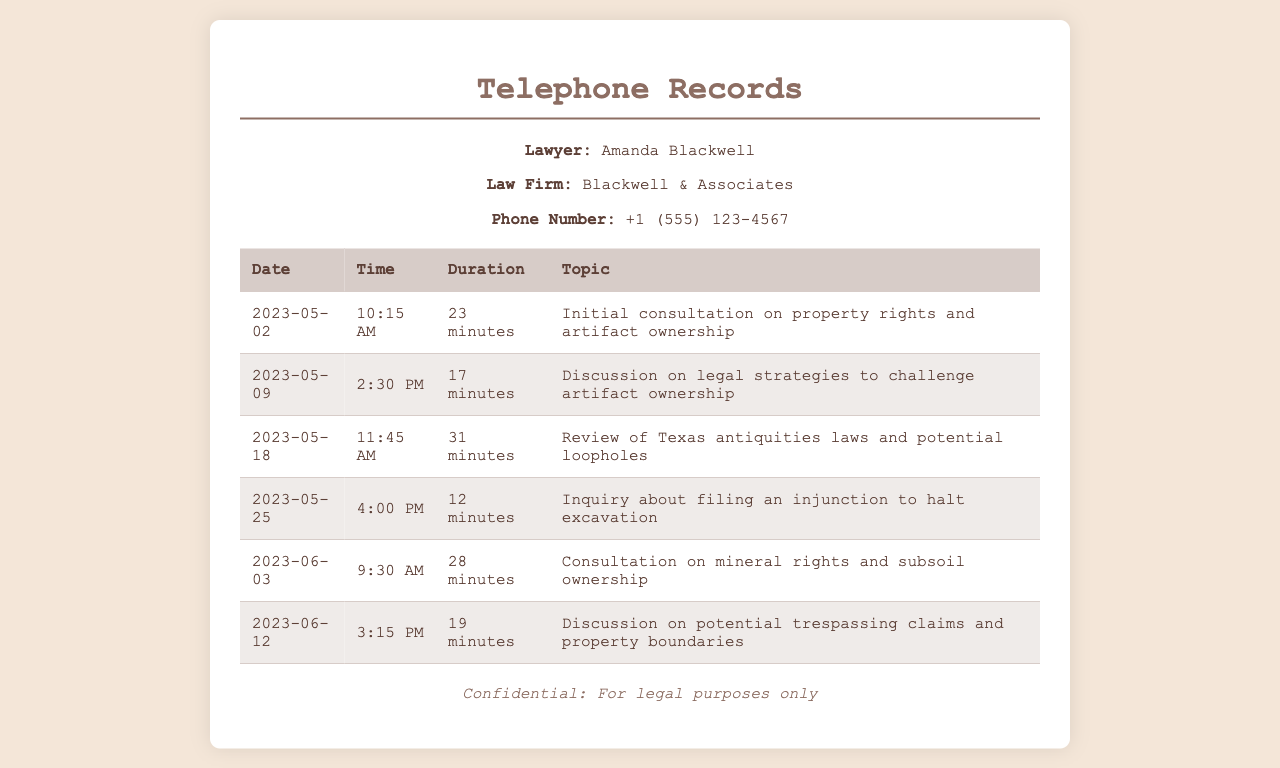What is the name of the lawyer? The lawyer's name is mentioned in the document under the lawyer info section.
Answer: Amanda Blackwell What is the phone number of the law firm? The law firm's phone number is listed in the lawyer info section.
Answer: +1 (555) 123-4567 How many minutes was the longest call? The duration of each call is provided in the table, and the longest duration can be found by comparing them.
Answer: 31 minutes On which date was the initial consultation held? The date of the initial consultation is specified in the first row of the table.
Answer: 2023-05-02 What was discussed on June 12, 2023? The topic of the call on this date is listed under the corresponding row in the table.
Answer: Potential trespassing claims and property boundaries How many calls were made to the lawyer? By counting the entries in the table, we can determine the total number of calls.
Answer: 6 calls What was the main topic of the call on May 25, 2023? The topic of this specific call is mentioned in the table.
Answer: Inquiry about filing an injunction to halt excavation What time did the call on May 18, 2023, take place? The exact time is provided in the corresponding row of the table.
Answer: 11:45 AM 